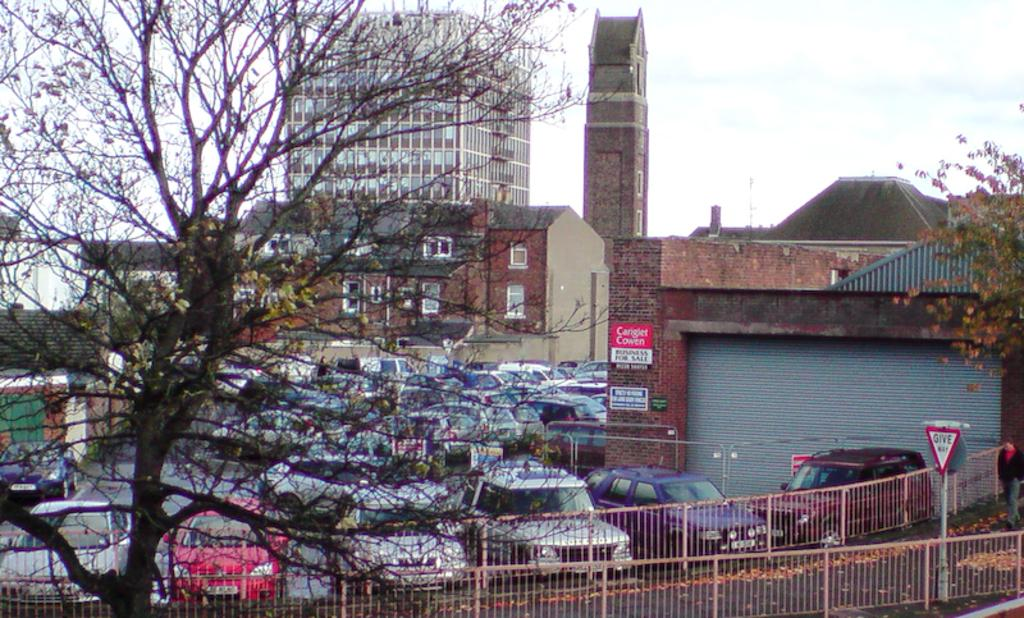What type of structure can be seen in the image? There is a railing in the image. What is attached to the pole in the image? There is a board attached to the pole in the image. What type of vegetation is present in the image? There are trees in the image. What type of man-made structures can be seen in the image? There are vehicles and buildings in the image. What is visible in the background of the image? The sky is visible in the background of the image. Can you see any cracks in the board on the pole in the image? There is no mention of any cracks in the board on the pole in the image. What type of flowers are growing near the trees in the image? There is no mention of any flowers in the image. 